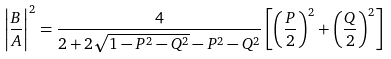Convert formula to latex. <formula><loc_0><loc_0><loc_500><loc_500>\left | \frac { B } { A } \right | ^ { 2 } = \frac { 4 } { 2 + 2 \sqrt { 1 - P ^ { 2 } - Q ^ { 2 } } - P ^ { 2 } - Q ^ { 2 } } \left [ \left ( \frac { P } { 2 } \right ) ^ { 2 } + \left ( \frac { Q } { 2 } \right ) ^ { 2 } \right ]</formula> 